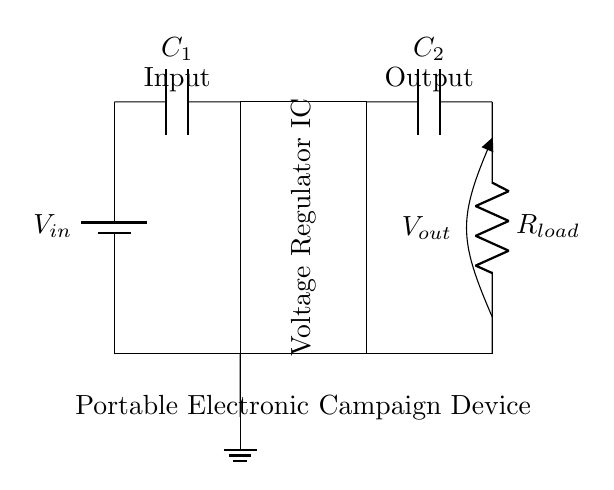What is the main function of the voltage regulator in this circuit? The main function of the voltage regulator is to maintain a constant output voltage regardless of variations in input voltage and load conditions.
Answer: To maintain constant voltage What type of capacitors are used in this circuit? The circuit shows two capacitors labeled as C1 and C2, which are typically electrolytic or ceramic capacitors used for filtering and stability.
Answer: Capacitors are C1 and C2 Where is the load resistor connected in this circuit? The load resistor is connected at the output side of the voltage regulator, linking the output voltage to ground.
Answer: Between output and ground What is the input voltage labeled as in the circuit? The input voltage is labeled as V-in, indicating it is the supply voltage before regulation.
Answer: V-in How many capacitors are included in the circuit diagram? There are two capacitors shown in the circuit: C1 and C2, both serving different purposes in the voltage regulation process.
Answer: Two capacitors What happens if the input voltage exceeds the rated maximum for the voltage regulator? If the input voltage exceeds the rated maximum, it could damage the voltage regulator or impair the overall circuit operation due to overheating or failure.
Answer: It could damage the regulator Why is C2 placed at the output side of the voltage regulator? C2 is placed at the output to stabilize the output voltage and filter any high-frequency noise that may be present, ensuring clean power delivery to the load.
Answer: To stabilize output voltage 